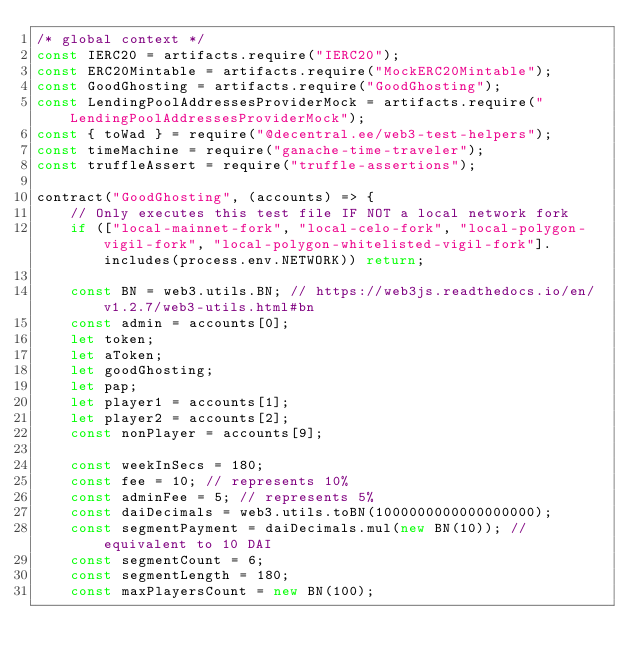<code> <loc_0><loc_0><loc_500><loc_500><_JavaScript_>/* global context */
const IERC20 = artifacts.require("IERC20");
const ERC20Mintable = artifacts.require("MockERC20Mintable");
const GoodGhosting = artifacts.require("GoodGhosting");
const LendingPoolAddressesProviderMock = artifacts.require("LendingPoolAddressesProviderMock");
const { toWad } = require("@decentral.ee/web3-test-helpers");
const timeMachine = require("ganache-time-traveler");
const truffleAssert = require("truffle-assertions");

contract("GoodGhosting", (accounts) => {
    // Only executes this test file IF NOT a local network fork
    if (["local-mainnet-fork", "local-celo-fork", "local-polygon-vigil-fork", "local-polygon-whitelisted-vigil-fork"].includes(process.env.NETWORK)) return;

    const BN = web3.utils.BN; // https://web3js.readthedocs.io/en/v1.2.7/web3-utils.html#bn
    const admin = accounts[0];
    let token;
    let aToken;
    let goodGhosting;
    let pap;
    let player1 = accounts[1];
    let player2 = accounts[2];
    const nonPlayer = accounts[9];

    const weekInSecs = 180;
    const fee = 10; // represents 10%
    const adminFee = 5; // represents 5%
    const daiDecimals = web3.utils.toBN(1000000000000000000);
    const segmentPayment = daiDecimals.mul(new BN(10)); // equivalent to 10 DAI
    const segmentCount = 6;
    const segmentLength = 180;
    const maxPlayersCount = new BN(100);</code> 